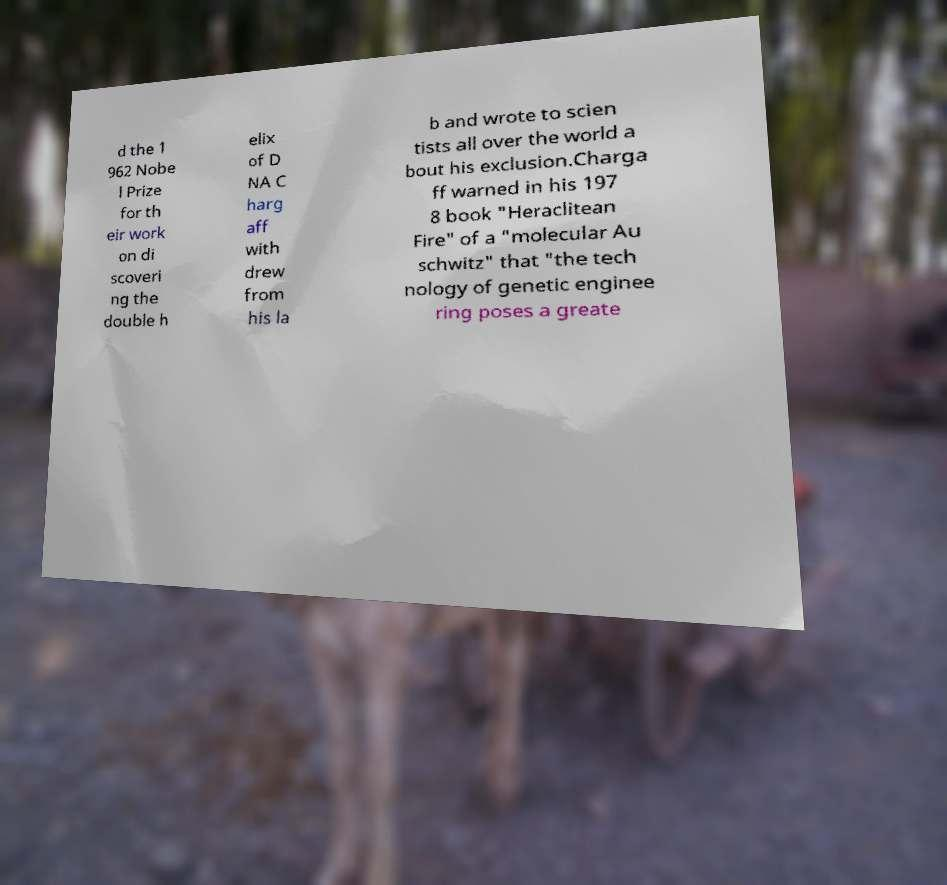What messages or text are displayed in this image? I need them in a readable, typed format. d the 1 962 Nobe l Prize for th eir work on di scoveri ng the double h elix of D NA C harg aff with drew from his la b and wrote to scien tists all over the world a bout his exclusion.Charga ff warned in his 197 8 book "Heraclitean Fire" of a "molecular Au schwitz" that "the tech nology of genetic enginee ring poses a greate 